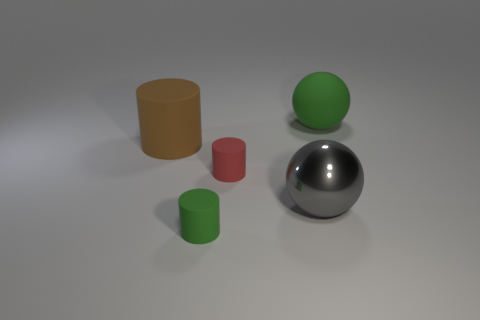Add 5 tiny cyan metal cubes. How many objects exist? 10 Subtract all brown rubber cylinders. How many cylinders are left? 2 Subtract 1 spheres. How many spheres are left? 1 Subtract all cylinders. How many objects are left? 2 Subtract all green balls. How many balls are left? 1 Subtract all brown spheres. Subtract all green cylinders. How many spheres are left? 2 Subtract all gray metallic things. Subtract all red things. How many objects are left? 3 Add 5 big green things. How many big green things are left? 6 Add 2 gray cylinders. How many gray cylinders exist? 2 Subtract 1 brown cylinders. How many objects are left? 4 